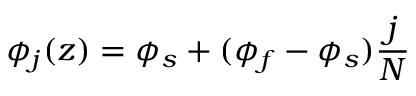Convert formula to latex. <formula><loc_0><loc_0><loc_500><loc_500>\phi _ { j } ( z ) = \phi _ { s } + ( \phi _ { f } - \phi _ { s } ) \frac { j } { N }</formula> 